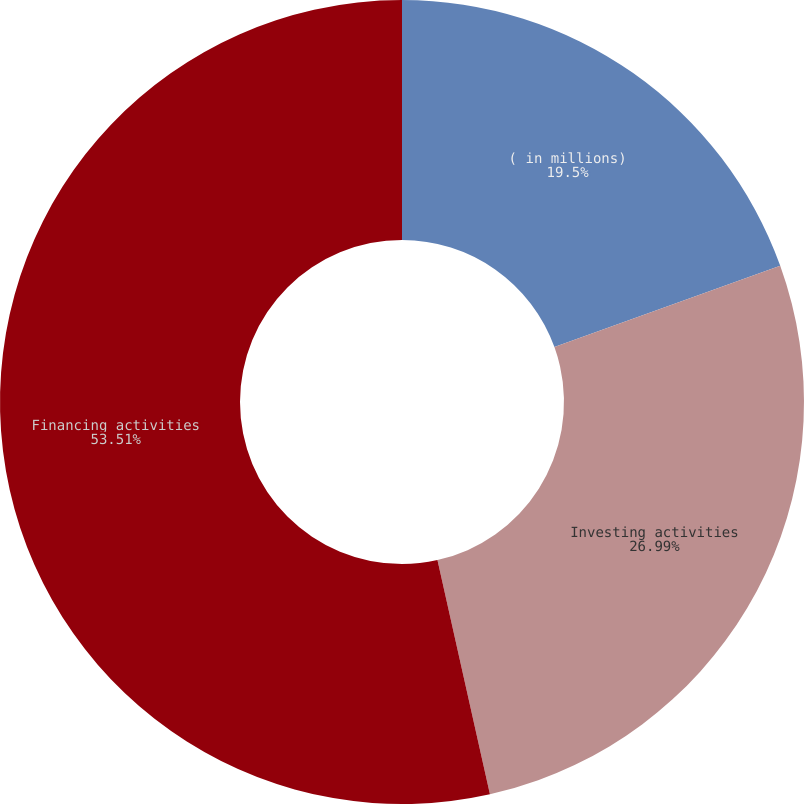<chart> <loc_0><loc_0><loc_500><loc_500><pie_chart><fcel>( in millions)<fcel>Investing activities<fcel>Financing activities<nl><fcel>19.5%<fcel>26.99%<fcel>53.51%<nl></chart> 